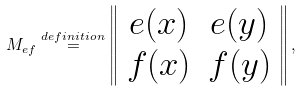Convert formula to latex. <formula><loc_0><loc_0><loc_500><loc_500>M _ { e f } \overset { d e f i n i t i o n } { = } \left \| \begin{array} [ c ] { c c } e ( x ) & e ( y ) \\ f ( x ) & f ( y ) \end{array} \right \| ,</formula> 